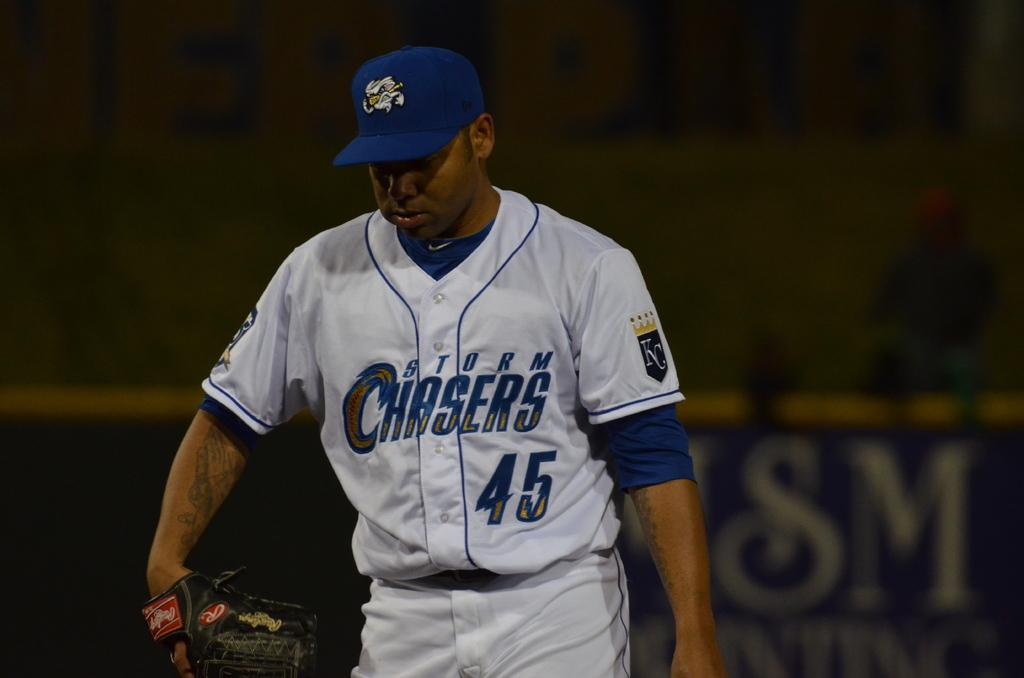<image>
Render a clear and concise summary of the photo. Kansas City Royals player 45 had a Storm Chasers logo on the front of his jersey as he headed onto the field with his glove. 